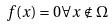<formula> <loc_0><loc_0><loc_500><loc_500>f ( x ) = 0 \forall x \notin \Omega</formula> 